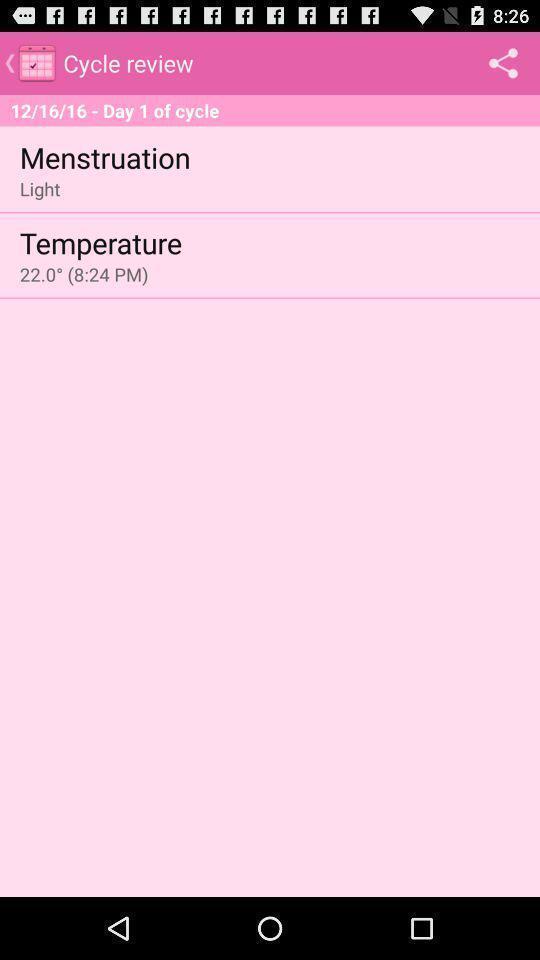Please provide a description for this image. Screen page displaying details of a menstruation application. 